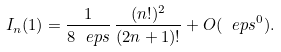<formula> <loc_0><loc_0><loc_500><loc_500>I _ { n } ( 1 ) = \frac { 1 } { 8 \ e p s } \, \frac { ( n ! ) ^ { 2 } } { ( 2 n + 1 ) ! } + O ( \ e p s ^ { 0 } ) .</formula> 